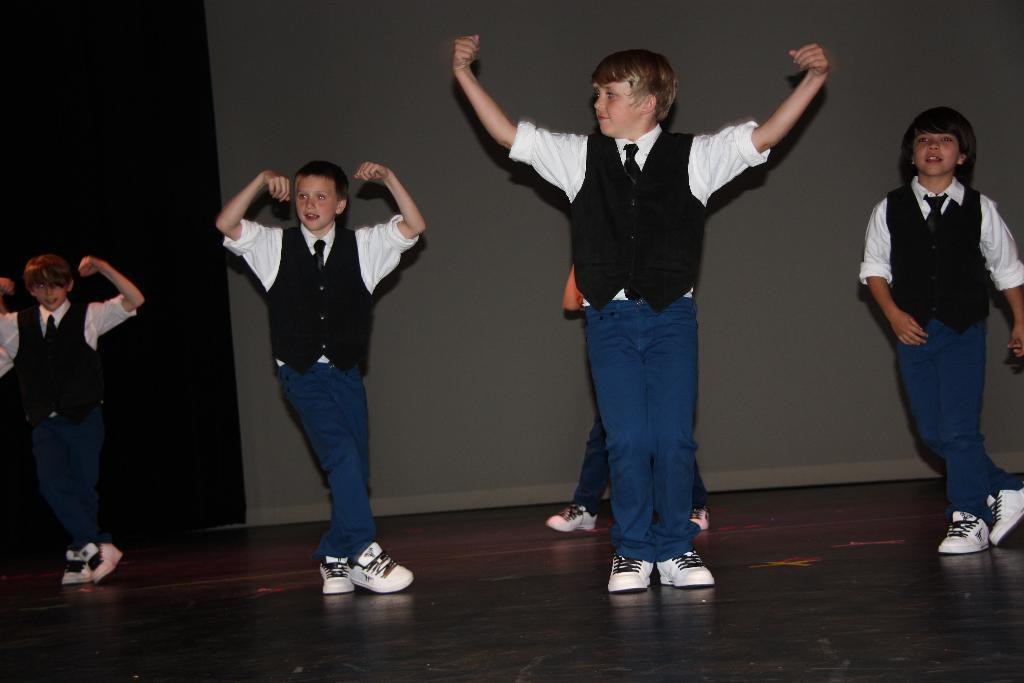How many kids are present in the image? There are five kids in the image. What are the kids doing in the image? The kids are dancing on a stage. What color are the shirts the kids are wearing? The kids are wearing white color shirts. What color are the vests the kids are wearing? The kids are wearing black color vests. What type of pants are the kids wearing? The kids are wearing blue jeans. What color are the shoes the kids are wearing? The kids are wearing white color shoes. What type of trains can be seen in the background of the image? There are no trains visible in the image; it features five kids dancing on a stage. What story is the kids acting out on the stage? The image does not provide any information about a story being acted out by the kids. 